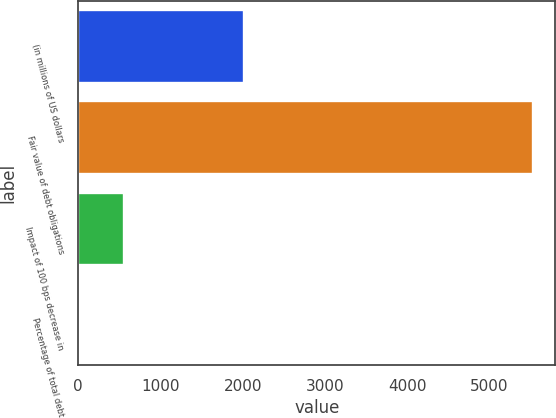<chart> <loc_0><loc_0><loc_500><loc_500><bar_chart><fcel>(in millions of US dollars<fcel>Fair value of debt obligations<fcel>Impact of 100 bps decrease in<fcel>Percentage of total debt<nl><fcel>2010<fcel>5522<fcel>556.79<fcel>5.1<nl></chart> 